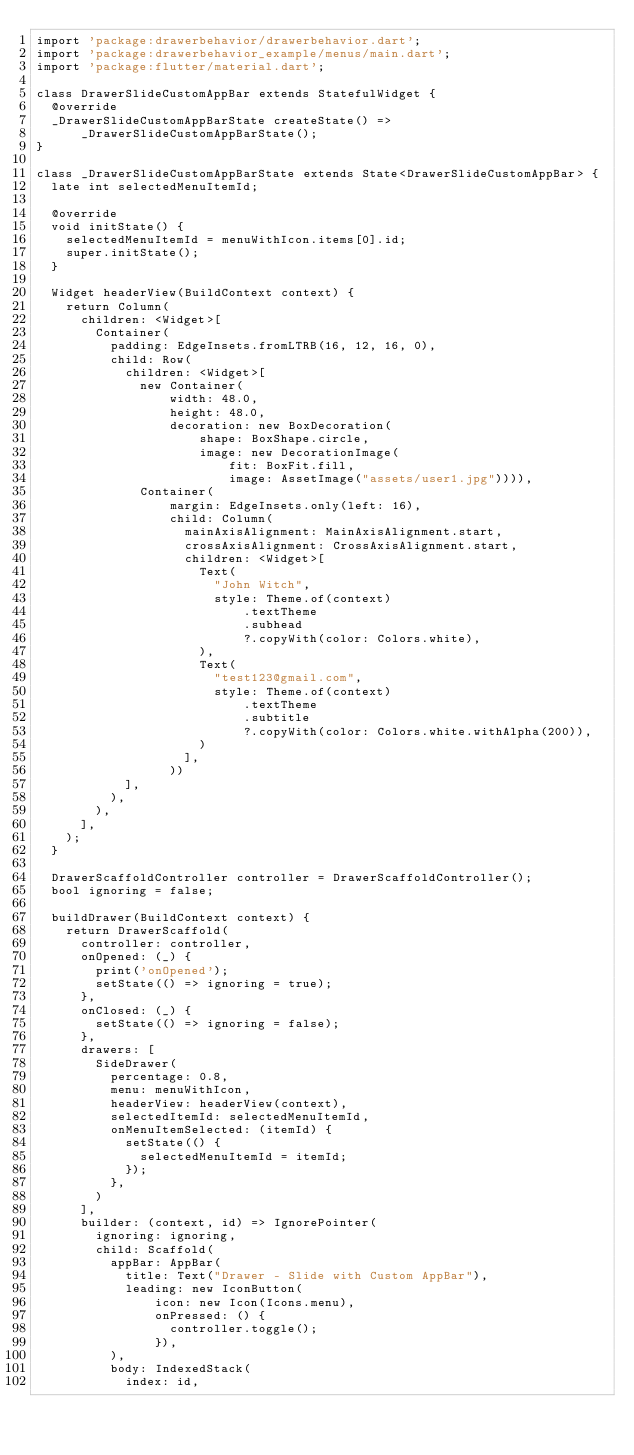Convert code to text. <code><loc_0><loc_0><loc_500><loc_500><_Dart_>import 'package:drawerbehavior/drawerbehavior.dart';
import 'package:drawerbehavior_example/menus/main.dart';
import 'package:flutter/material.dart';

class DrawerSlideCustomAppBar extends StatefulWidget {
  @override
  _DrawerSlideCustomAppBarState createState() =>
      _DrawerSlideCustomAppBarState();
}

class _DrawerSlideCustomAppBarState extends State<DrawerSlideCustomAppBar> {
  late int selectedMenuItemId;

  @override
  void initState() {
    selectedMenuItemId = menuWithIcon.items[0].id;
    super.initState();
  }

  Widget headerView(BuildContext context) {
    return Column(
      children: <Widget>[
        Container(
          padding: EdgeInsets.fromLTRB(16, 12, 16, 0),
          child: Row(
            children: <Widget>[
              new Container(
                  width: 48.0,
                  height: 48.0,
                  decoration: new BoxDecoration(
                      shape: BoxShape.circle,
                      image: new DecorationImage(
                          fit: BoxFit.fill,
                          image: AssetImage("assets/user1.jpg")))),
              Container(
                  margin: EdgeInsets.only(left: 16),
                  child: Column(
                    mainAxisAlignment: MainAxisAlignment.start,
                    crossAxisAlignment: CrossAxisAlignment.start,
                    children: <Widget>[
                      Text(
                        "John Witch",
                        style: Theme.of(context)
                            .textTheme
                            .subhead
                            ?.copyWith(color: Colors.white),
                      ),
                      Text(
                        "test123@gmail.com",
                        style: Theme.of(context)
                            .textTheme
                            .subtitle
                            ?.copyWith(color: Colors.white.withAlpha(200)),
                      )
                    ],
                  ))
            ],
          ),
        ),
      ],
    );
  }

  DrawerScaffoldController controller = DrawerScaffoldController();
  bool ignoring = false;

  buildDrawer(BuildContext context) {
    return DrawerScaffold(
      controller: controller,
      onOpened: (_) {
        print('onOpened');
        setState(() => ignoring = true);
      },
      onClosed: (_) {
        setState(() => ignoring = false);
      },
      drawers: [
        SideDrawer(
          percentage: 0.8,
          menu: menuWithIcon,
          headerView: headerView(context),
          selectedItemId: selectedMenuItemId,
          onMenuItemSelected: (itemId) {
            setState(() {
              selectedMenuItemId = itemId;
            });
          },
        )
      ],
      builder: (context, id) => IgnorePointer(
        ignoring: ignoring,
        child: Scaffold(
          appBar: AppBar(
            title: Text("Drawer - Slide with Custom AppBar"),
            leading: new IconButton(
                icon: new Icon(Icons.menu),
                onPressed: () {
                  controller.toggle();
                }),
          ),
          body: IndexedStack(
            index: id,</code> 